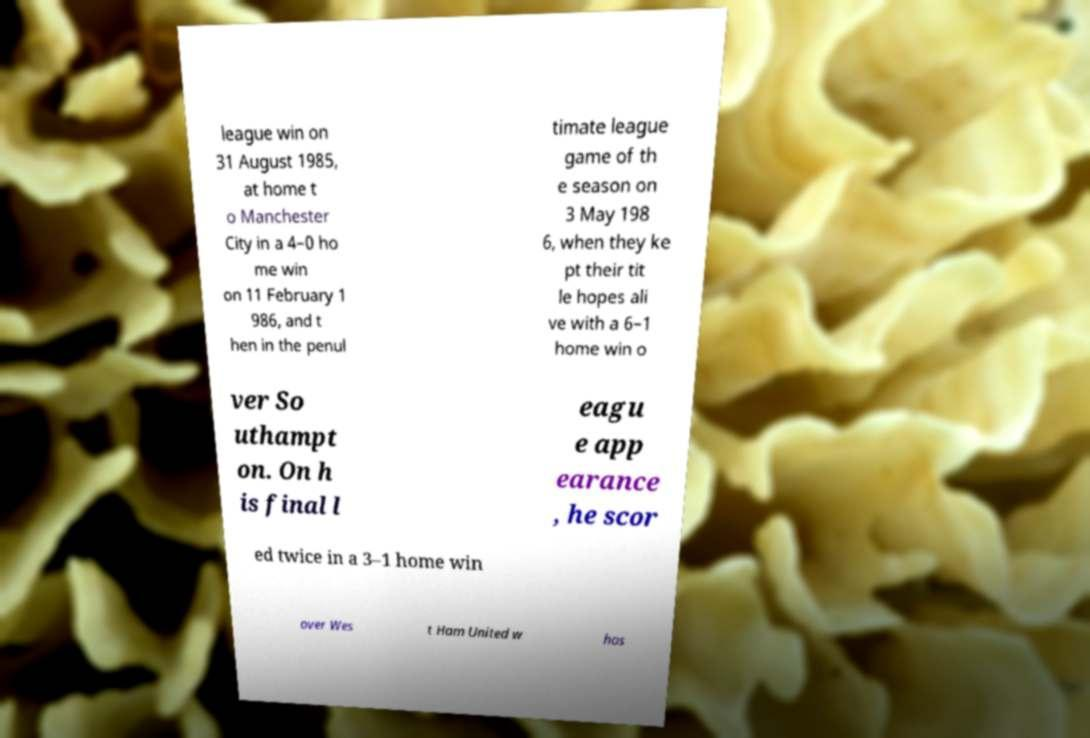I need the written content from this picture converted into text. Can you do that? league win on 31 August 1985, at home t o Manchester City in a 4–0 ho me win on 11 February 1 986, and t hen in the penul timate league game of th e season on 3 May 198 6, when they ke pt their tit le hopes ali ve with a 6–1 home win o ver So uthampt on. On h is final l eagu e app earance , he scor ed twice in a 3–1 home win over Wes t Ham United w hos 